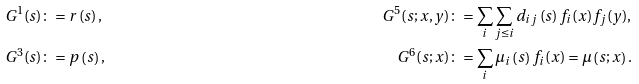<formula> <loc_0><loc_0><loc_500><loc_500>& G ^ { 1 } ( s ) \colon = r \left ( s \right ) , & G ^ { 5 } ( s ; x , y ) & \colon = \sum _ { i } \sum _ { j \leq i } d _ { i j } \left ( s \right ) f _ { i } ( x ) f _ { j } ( y ) , \\ & G ^ { 3 } ( s ) \colon = p \left ( s \right ) , & G ^ { 6 } ( s ; x ) & \colon = \sum _ { i } \mu _ { i } \left ( s \right ) f _ { i } ( x ) = \mu \left ( s ; x \right ) .</formula> 